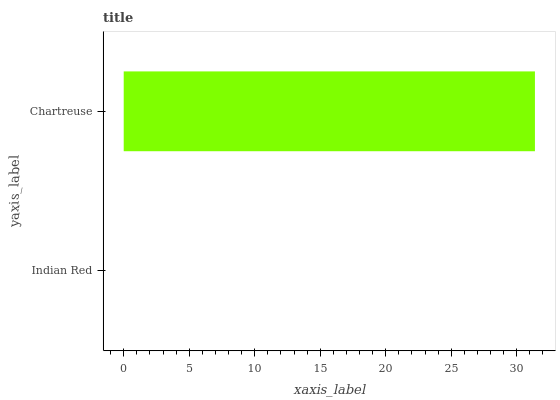Is Indian Red the minimum?
Answer yes or no. Yes. Is Chartreuse the maximum?
Answer yes or no. Yes. Is Chartreuse the minimum?
Answer yes or no. No. Is Chartreuse greater than Indian Red?
Answer yes or no. Yes. Is Indian Red less than Chartreuse?
Answer yes or no. Yes. Is Indian Red greater than Chartreuse?
Answer yes or no. No. Is Chartreuse less than Indian Red?
Answer yes or no. No. Is Chartreuse the high median?
Answer yes or no. Yes. Is Indian Red the low median?
Answer yes or no. Yes. Is Indian Red the high median?
Answer yes or no. No. Is Chartreuse the low median?
Answer yes or no. No. 